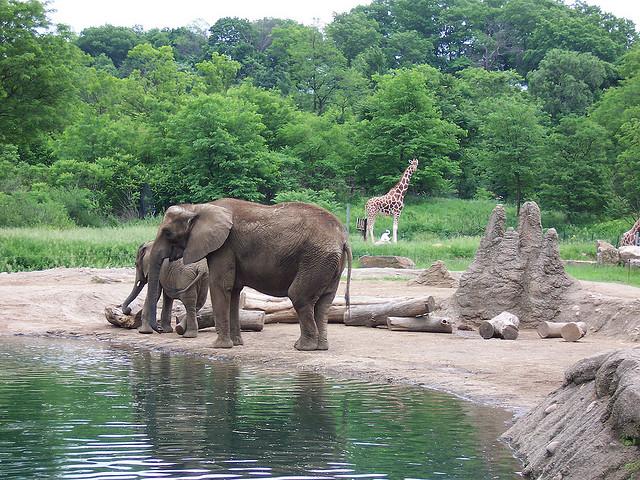What two animals are pictured?
Quick response, please. Elephant and giraffe. How many tails are visible in the picture?
Be succinct. 1. Where are the animals at?
Be succinct. Watering hole. 